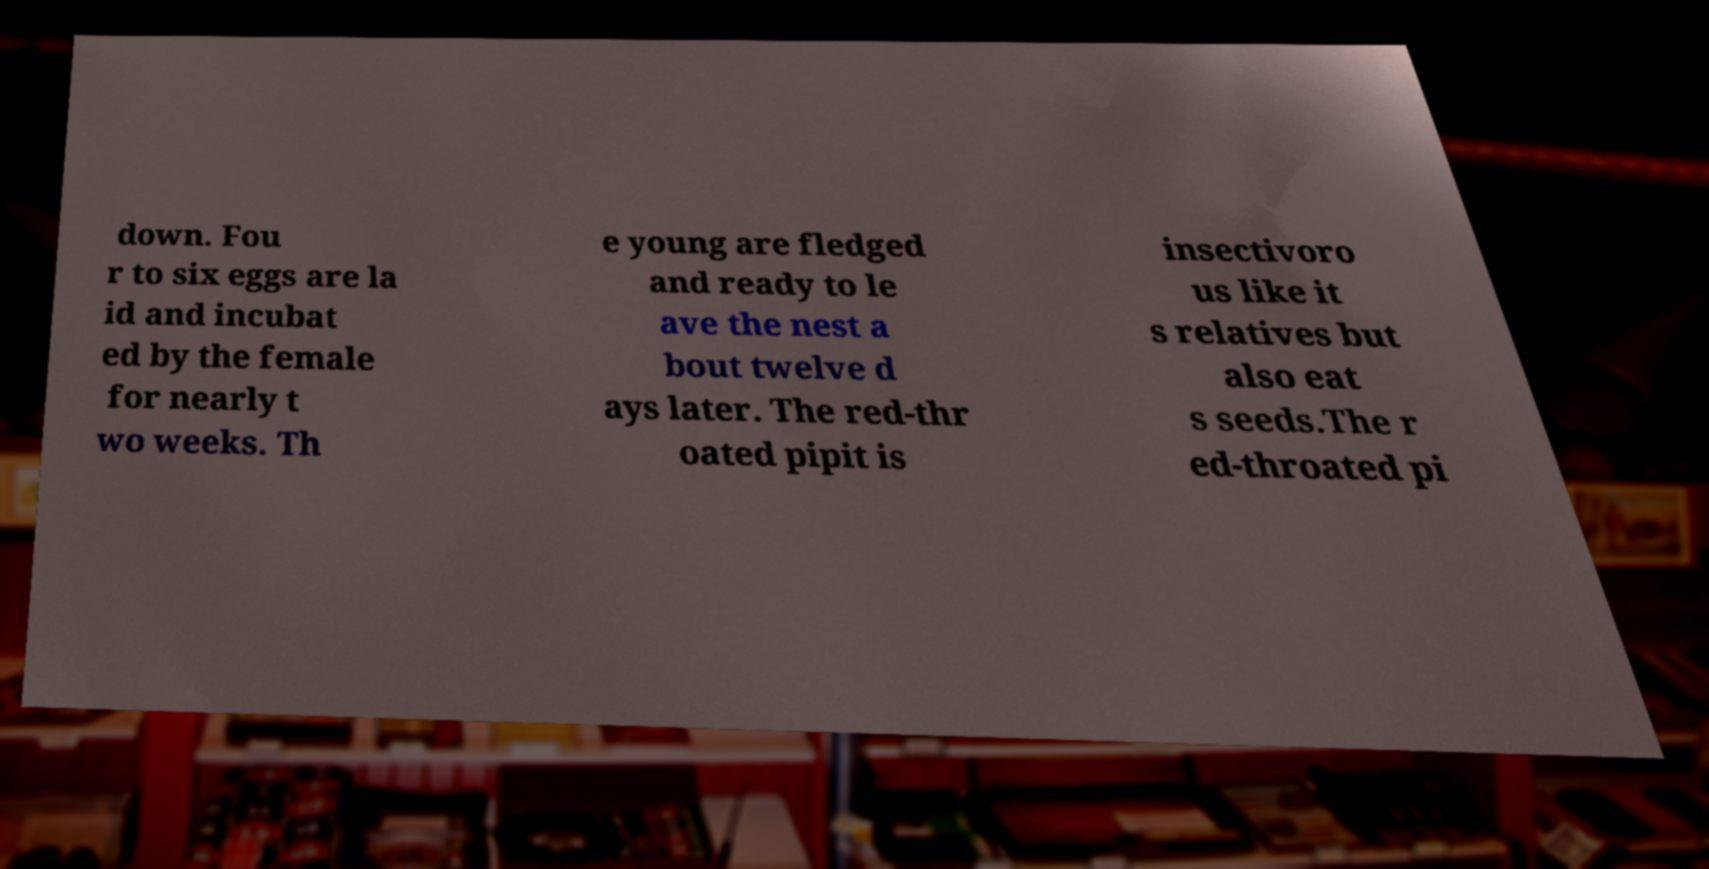Please identify and transcribe the text found in this image. down. Fou r to six eggs are la id and incubat ed by the female for nearly t wo weeks. Th e young are fledged and ready to le ave the nest a bout twelve d ays later. The red-thr oated pipit is insectivoro us like it s relatives but also eat s seeds.The r ed-throated pi 